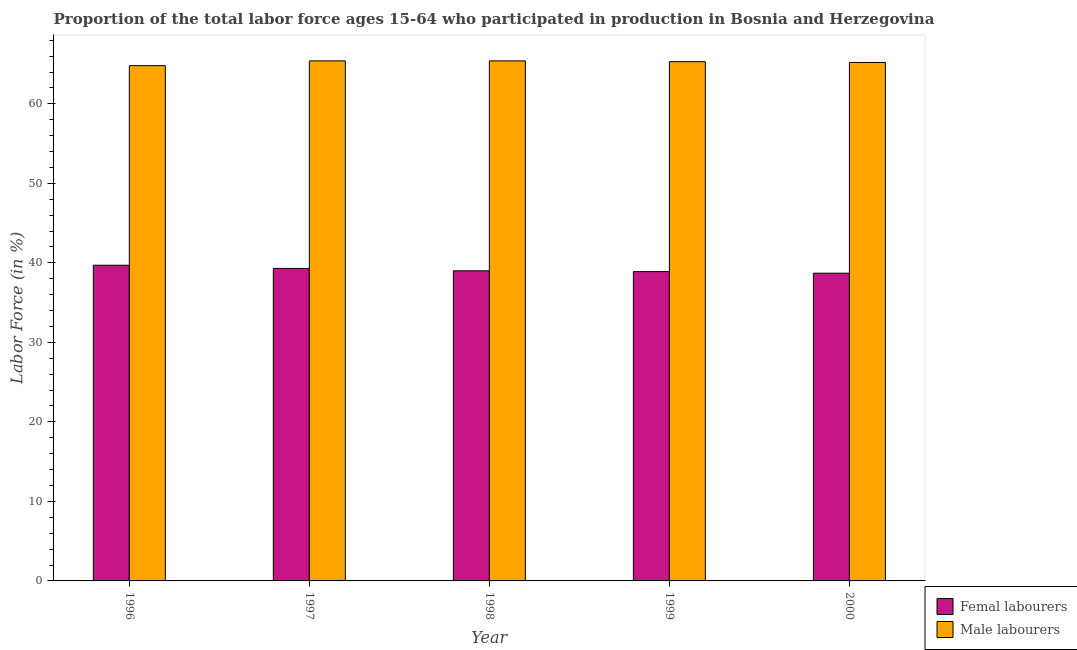How many groups of bars are there?
Your response must be concise. 5. What is the label of the 3rd group of bars from the left?
Keep it short and to the point. 1998. What is the percentage of male labour force in 1996?
Keep it short and to the point. 64.8. Across all years, what is the maximum percentage of female labor force?
Give a very brief answer. 39.7. Across all years, what is the minimum percentage of male labour force?
Your answer should be very brief. 64.8. In which year was the percentage of female labor force maximum?
Offer a terse response. 1996. In which year was the percentage of male labour force minimum?
Give a very brief answer. 1996. What is the total percentage of male labour force in the graph?
Ensure brevity in your answer.  326.1. What is the difference between the percentage of female labor force in 1997 and that in 1998?
Make the answer very short. 0.3. What is the difference between the percentage of male labour force in 2000 and the percentage of female labor force in 1998?
Offer a very short reply. -0.2. What is the average percentage of male labour force per year?
Provide a short and direct response. 65.22. In the year 2000, what is the difference between the percentage of male labour force and percentage of female labor force?
Provide a short and direct response. 0. What is the ratio of the percentage of male labour force in 1999 to that in 2000?
Offer a very short reply. 1. What is the difference between the highest and the second highest percentage of female labor force?
Your answer should be compact. 0.4. What is the difference between the highest and the lowest percentage of male labour force?
Keep it short and to the point. 0.6. In how many years, is the percentage of male labour force greater than the average percentage of male labour force taken over all years?
Make the answer very short. 3. Is the sum of the percentage of female labor force in 1996 and 1998 greater than the maximum percentage of male labour force across all years?
Ensure brevity in your answer.  Yes. What does the 1st bar from the left in 1998 represents?
Keep it short and to the point. Femal labourers. What does the 1st bar from the right in 1996 represents?
Your answer should be very brief. Male labourers. How many bars are there?
Provide a short and direct response. 10. What is the difference between two consecutive major ticks on the Y-axis?
Give a very brief answer. 10. Are the values on the major ticks of Y-axis written in scientific E-notation?
Ensure brevity in your answer.  No. Does the graph contain any zero values?
Your response must be concise. No. Where does the legend appear in the graph?
Your answer should be compact. Bottom right. What is the title of the graph?
Your answer should be very brief. Proportion of the total labor force ages 15-64 who participated in production in Bosnia and Herzegovina. What is the label or title of the Y-axis?
Ensure brevity in your answer.  Labor Force (in %). What is the Labor Force (in %) of Femal labourers in 1996?
Provide a succinct answer. 39.7. What is the Labor Force (in %) of Male labourers in 1996?
Provide a short and direct response. 64.8. What is the Labor Force (in %) of Femal labourers in 1997?
Your response must be concise. 39.3. What is the Labor Force (in %) in Male labourers in 1997?
Provide a succinct answer. 65.4. What is the Labor Force (in %) of Femal labourers in 1998?
Provide a succinct answer. 39. What is the Labor Force (in %) in Male labourers in 1998?
Make the answer very short. 65.4. What is the Labor Force (in %) of Femal labourers in 1999?
Ensure brevity in your answer.  38.9. What is the Labor Force (in %) in Male labourers in 1999?
Give a very brief answer. 65.3. What is the Labor Force (in %) of Femal labourers in 2000?
Your response must be concise. 38.7. What is the Labor Force (in %) in Male labourers in 2000?
Give a very brief answer. 65.2. Across all years, what is the maximum Labor Force (in %) of Femal labourers?
Ensure brevity in your answer.  39.7. Across all years, what is the maximum Labor Force (in %) of Male labourers?
Keep it short and to the point. 65.4. Across all years, what is the minimum Labor Force (in %) in Femal labourers?
Keep it short and to the point. 38.7. Across all years, what is the minimum Labor Force (in %) in Male labourers?
Offer a very short reply. 64.8. What is the total Labor Force (in %) of Femal labourers in the graph?
Provide a short and direct response. 195.6. What is the total Labor Force (in %) in Male labourers in the graph?
Keep it short and to the point. 326.1. What is the difference between the Labor Force (in %) in Femal labourers in 1996 and that in 1997?
Give a very brief answer. 0.4. What is the difference between the Labor Force (in %) in Femal labourers in 1996 and that in 1998?
Keep it short and to the point. 0.7. What is the difference between the Labor Force (in %) in Male labourers in 1996 and that in 1998?
Provide a succinct answer. -0.6. What is the difference between the Labor Force (in %) in Femal labourers in 1996 and that in 1999?
Keep it short and to the point. 0.8. What is the difference between the Labor Force (in %) of Male labourers in 1996 and that in 1999?
Provide a succinct answer. -0.5. What is the difference between the Labor Force (in %) of Femal labourers in 1996 and that in 2000?
Provide a short and direct response. 1. What is the difference between the Labor Force (in %) in Male labourers in 1997 and that in 1998?
Keep it short and to the point. 0. What is the difference between the Labor Force (in %) of Male labourers in 1997 and that in 1999?
Make the answer very short. 0.1. What is the difference between the Labor Force (in %) of Male labourers in 1997 and that in 2000?
Offer a terse response. 0.2. What is the difference between the Labor Force (in %) of Male labourers in 1998 and that in 1999?
Your response must be concise. 0.1. What is the difference between the Labor Force (in %) in Femal labourers in 1998 and that in 2000?
Your answer should be compact. 0.3. What is the difference between the Labor Force (in %) in Male labourers in 1998 and that in 2000?
Offer a very short reply. 0.2. What is the difference between the Labor Force (in %) in Femal labourers in 1999 and that in 2000?
Provide a succinct answer. 0.2. What is the difference between the Labor Force (in %) in Male labourers in 1999 and that in 2000?
Your response must be concise. 0.1. What is the difference between the Labor Force (in %) in Femal labourers in 1996 and the Labor Force (in %) in Male labourers in 1997?
Ensure brevity in your answer.  -25.7. What is the difference between the Labor Force (in %) of Femal labourers in 1996 and the Labor Force (in %) of Male labourers in 1998?
Make the answer very short. -25.7. What is the difference between the Labor Force (in %) of Femal labourers in 1996 and the Labor Force (in %) of Male labourers in 1999?
Give a very brief answer. -25.6. What is the difference between the Labor Force (in %) in Femal labourers in 1996 and the Labor Force (in %) in Male labourers in 2000?
Give a very brief answer. -25.5. What is the difference between the Labor Force (in %) in Femal labourers in 1997 and the Labor Force (in %) in Male labourers in 1998?
Your answer should be compact. -26.1. What is the difference between the Labor Force (in %) in Femal labourers in 1997 and the Labor Force (in %) in Male labourers in 2000?
Make the answer very short. -25.9. What is the difference between the Labor Force (in %) of Femal labourers in 1998 and the Labor Force (in %) of Male labourers in 1999?
Give a very brief answer. -26.3. What is the difference between the Labor Force (in %) of Femal labourers in 1998 and the Labor Force (in %) of Male labourers in 2000?
Give a very brief answer. -26.2. What is the difference between the Labor Force (in %) of Femal labourers in 1999 and the Labor Force (in %) of Male labourers in 2000?
Provide a succinct answer. -26.3. What is the average Labor Force (in %) of Femal labourers per year?
Provide a short and direct response. 39.12. What is the average Labor Force (in %) of Male labourers per year?
Your answer should be very brief. 65.22. In the year 1996, what is the difference between the Labor Force (in %) of Femal labourers and Labor Force (in %) of Male labourers?
Provide a succinct answer. -25.1. In the year 1997, what is the difference between the Labor Force (in %) of Femal labourers and Labor Force (in %) of Male labourers?
Provide a short and direct response. -26.1. In the year 1998, what is the difference between the Labor Force (in %) of Femal labourers and Labor Force (in %) of Male labourers?
Provide a succinct answer. -26.4. In the year 1999, what is the difference between the Labor Force (in %) in Femal labourers and Labor Force (in %) in Male labourers?
Your answer should be very brief. -26.4. In the year 2000, what is the difference between the Labor Force (in %) in Femal labourers and Labor Force (in %) in Male labourers?
Keep it short and to the point. -26.5. What is the ratio of the Labor Force (in %) in Femal labourers in 1996 to that in 1997?
Ensure brevity in your answer.  1.01. What is the ratio of the Labor Force (in %) in Male labourers in 1996 to that in 1997?
Your answer should be very brief. 0.99. What is the ratio of the Labor Force (in %) of Femal labourers in 1996 to that in 1998?
Provide a short and direct response. 1.02. What is the ratio of the Labor Force (in %) of Femal labourers in 1996 to that in 1999?
Offer a terse response. 1.02. What is the ratio of the Labor Force (in %) in Male labourers in 1996 to that in 1999?
Offer a terse response. 0.99. What is the ratio of the Labor Force (in %) in Femal labourers in 1996 to that in 2000?
Ensure brevity in your answer.  1.03. What is the ratio of the Labor Force (in %) in Femal labourers in 1997 to that in 1998?
Ensure brevity in your answer.  1.01. What is the ratio of the Labor Force (in %) of Male labourers in 1997 to that in 1998?
Give a very brief answer. 1. What is the ratio of the Labor Force (in %) in Femal labourers in 1997 to that in 1999?
Your answer should be very brief. 1.01. What is the ratio of the Labor Force (in %) of Male labourers in 1997 to that in 1999?
Make the answer very short. 1. What is the ratio of the Labor Force (in %) of Femal labourers in 1997 to that in 2000?
Make the answer very short. 1.02. What is the ratio of the Labor Force (in %) of Femal labourers in 1998 to that in 1999?
Ensure brevity in your answer.  1. What is the ratio of the Labor Force (in %) in Male labourers in 1998 to that in 1999?
Offer a terse response. 1. What is the ratio of the Labor Force (in %) in Femal labourers in 1998 to that in 2000?
Give a very brief answer. 1.01. What is the ratio of the Labor Force (in %) in Male labourers in 1998 to that in 2000?
Provide a succinct answer. 1. What is the ratio of the Labor Force (in %) in Femal labourers in 1999 to that in 2000?
Ensure brevity in your answer.  1.01. What is the difference between the highest and the second highest Labor Force (in %) of Male labourers?
Make the answer very short. 0. 